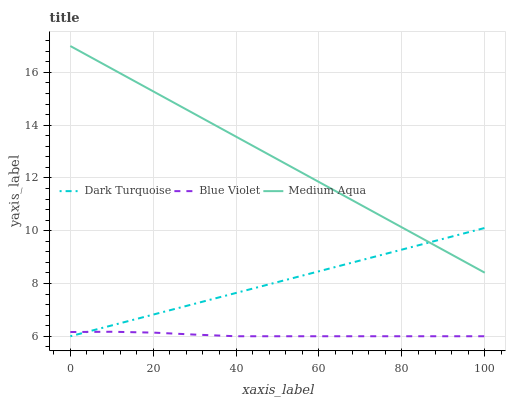Does Blue Violet have the minimum area under the curve?
Answer yes or no. Yes. Does Medium Aqua have the maximum area under the curve?
Answer yes or no. Yes. Does Medium Aqua have the minimum area under the curve?
Answer yes or no. No. Does Blue Violet have the maximum area under the curve?
Answer yes or no. No. Is Dark Turquoise the smoothest?
Answer yes or no. Yes. Is Blue Violet the roughest?
Answer yes or no. Yes. Is Medium Aqua the smoothest?
Answer yes or no. No. Is Medium Aqua the roughest?
Answer yes or no. No. Does Dark Turquoise have the lowest value?
Answer yes or no. Yes. Does Medium Aqua have the lowest value?
Answer yes or no. No. Does Medium Aqua have the highest value?
Answer yes or no. Yes. Does Blue Violet have the highest value?
Answer yes or no. No. Is Blue Violet less than Medium Aqua?
Answer yes or no. Yes. Is Medium Aqua greater than Blue Violet?
Answer yes or no. Yes. Does Medium Aqua intersect Dark Turquoise?
Answer yes or no. Yes. Is Medium Aqua less than Dark Turquoise?
Answer yes or no. No. Is Medium Aqua greater than Dark Turquoise?
Answer yes or no. No. Does Blue Violet intersect Medium Aqua?
Answer yes or no. No. 